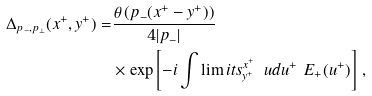Convert formula to latex. <formula><loc_0><loc_0><loc_500><loc_500>\Delta _ { p _ { - } , p _ { \perp } } ( x ^ { + } , y ^ { + } ) = & \frac { \theta \left ( p _ { - } ( x ^ { + } - y ^ { + } ) \right ) } { 4 | p _ { - } | } \\ & \times \exp \left [ - i \int \lim i t s _ { y ^ { + } } ^ { x ^ { + } } \, \ u d u ^ { + } \ E _ { + } ( u ^ { + } ) \right ] \, ,</formula> 